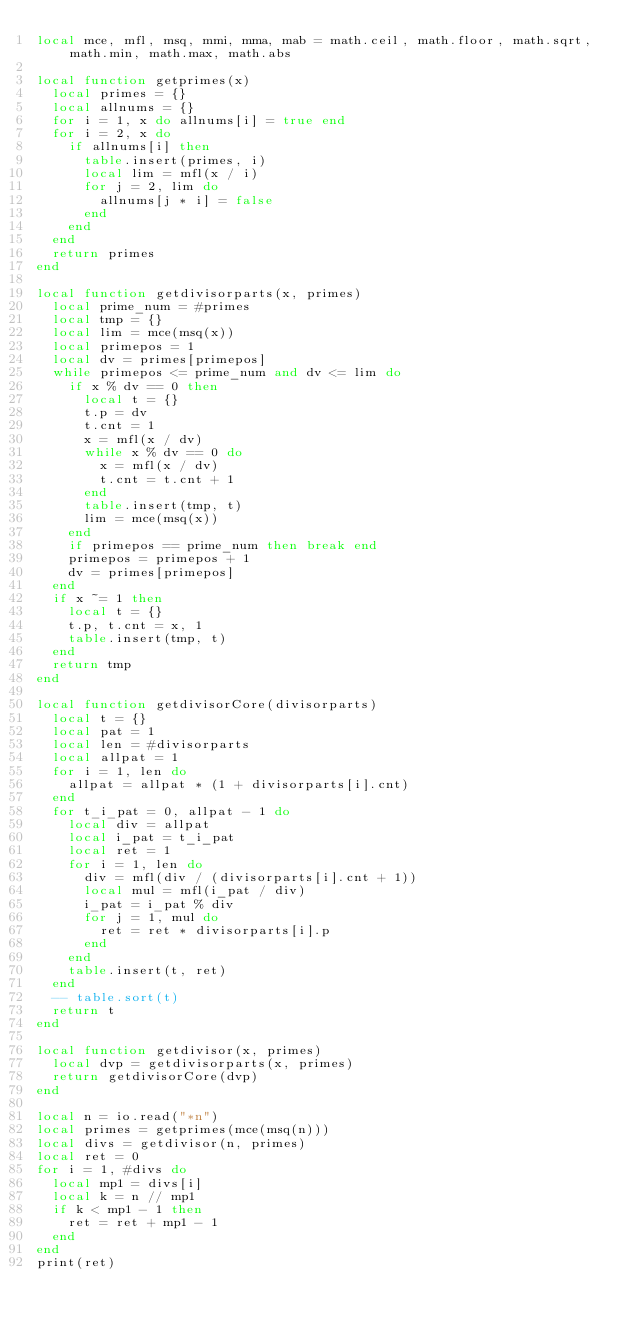<code> <loc_0><loc_0><loc_500><loc_500><_Lua_>local mce, mfl, msq, mmi, mma, mab = math.ceil, math.floor, math.sqrt, math.min, math.max, math.abs

local function getprimes(x)
  local primes = {}
  local allnums = {}
  for i = 1, x do allnums[i] = true end
  for i = 2, x do
    if allnums[i] then
      table.insert(primes, i)
      local lim = mfl(x / i)
      for j = 2, lim do
        allnums[j * i] = false
      end
    end
  end
  return primes
end

local function getdivisorparts(x, primes)
  local prime_num = #primes
  local tmp = {}
  local lim = mce(msq(x))
  local primepos = 1
  local dv = primes[primepos]
  while primepos <= prime_num and dv <= lim do
    if x % dv == 0 then
      local t = {}
      t.p = dv
      t.cnt = 1
      x = mfl(x / dv)
      while x % dv == 0 do
        x = mfl(x / dv)
        t.cnt = t.cnt + 1
      end
      table.insert(tmp, t)
      lim = mce(msq(x))
    end
    if primepos == prime_num then break end
    primepos = primepos + 1
    dv = primes[primepos]
  end
  if x ~= 1 then
    local t = {}
    t.p, t.cnt = x, 1
    table.insert(tmp, t)
  end
  return tmp
end

local function getdivisorCore(divisorparts)
  local t = {}
  local pat = 1
  local len = #divisorparts
  local allpat = 1
  for i = 1, len do
    allpat = allpat * (1 + divisorparts[i].cnt)
  end
  for t_i_pat = 0, allpat - 1 do
    local div = allpat
    local i_pat = t_i_pat
    local ret = 1
    for i = 1, len do
      div = mfl(div / (divisorparts[i].cnt + 1))
      local mul = mfl(i_pat / div)
      i_pat = i_pat % div
      for j = 1, mul do
        ret = ret * divisorparts[i].p
      end
    end
    table.insert(t, ret)
  end
  -- table.sort(t)
  return t
end

local function getdivisor(x, primes)
  local dvp = getdivisorparts(x, primes)
  return getdivisorCore(dvp)
end

local n = io.read("*n")
local primes = getprimes(mce(msq(n)))
local divs = getdivisor(n, primes)
local ret = 0
for i = 1, #divs do
  local mp1 = divs[i]
  local k = n // mp1
  if k < mp1 - 1 then
    ret = ret + mp1 - 1
  end
end
print(ret)</code> 